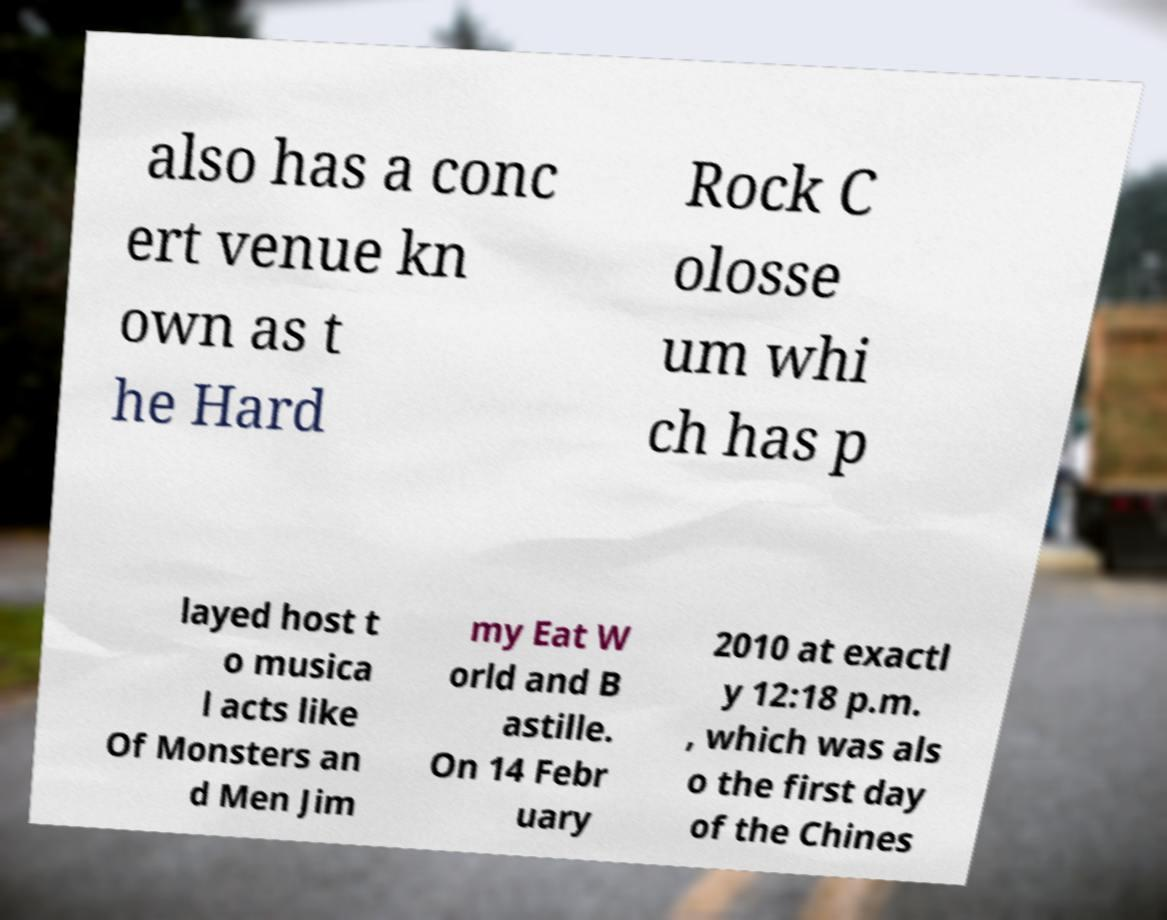Please read and relay the text visible in this image. What does it say? also has a conc ert venue kn own as t he Hard Rock C olosse um whi ch has p layed host t o musica l acts like Of Monsters an d Men Jim my Eat W orld and B astille. On 14 Febr uary 2010 at exactl y 12:18 p.m. , which was als o the first day of the Chines 